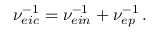<formula> <loc_0><loc_0><loc_500><loc_500>\nu _ { e i c } ^ { - 1 } = \nu _ { e i n } ^ { - 1 } + \nu _ { e p } ^ { - 1 } \, .</formula> 